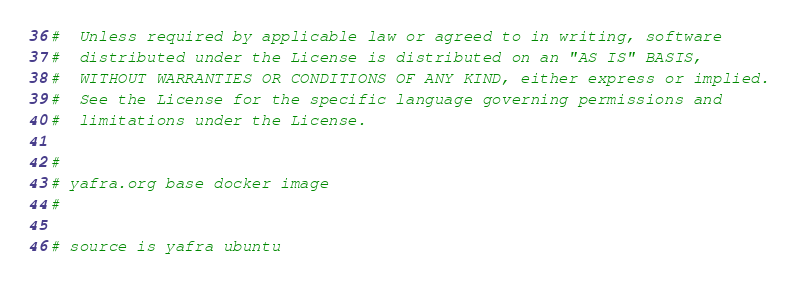<code> <loc_0><loc_0><loc_500><loc_500><_Dockerfile_>#  Unless required by applicable law or agreed to in writing, software
#  distributed under the License is distributed on an "AS IS" BASIS,
#  WITHOUT WARRANTIES OR CONDITIONS OF ANY KIND, either express or implied.
#  See the License for the specific language governing permissions and
#  limitations under the License.

#
# yafra.org base docker image
#

# source is yafra ubuntu</code> 